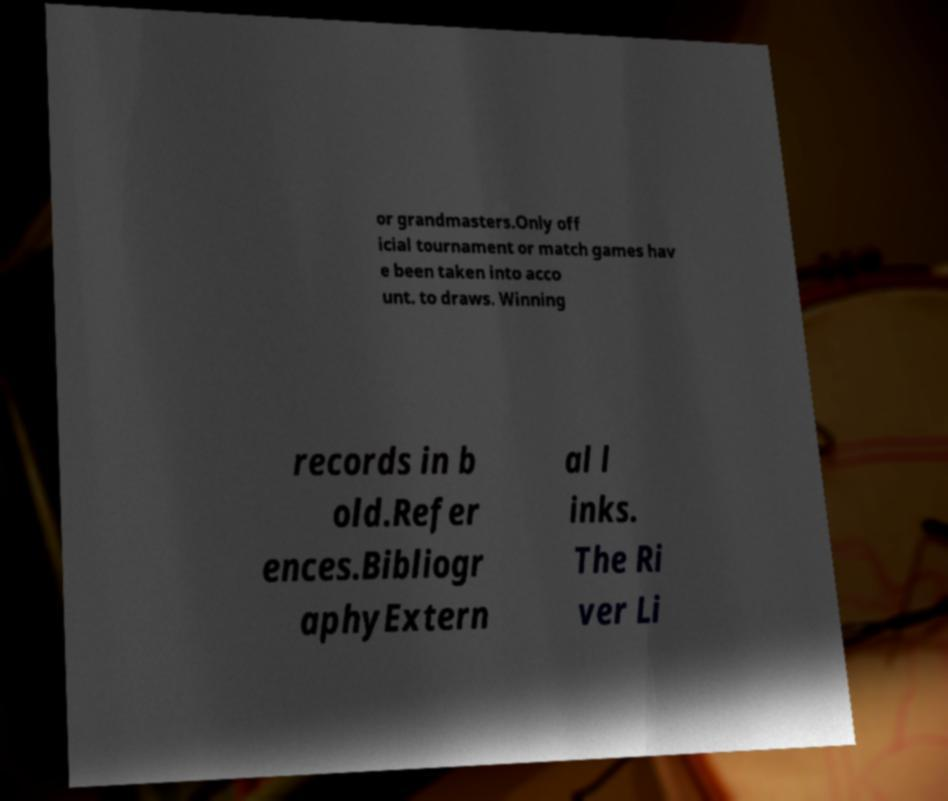I need the written content from this picture converted into text. Can you do that? or grandmasters.Only off icial tournament or match games hav e been taken into acco unt. to draws. Winning records in b old.Refer ences.Bibliogr aphyExtern al l inks. The Ri ver Li 